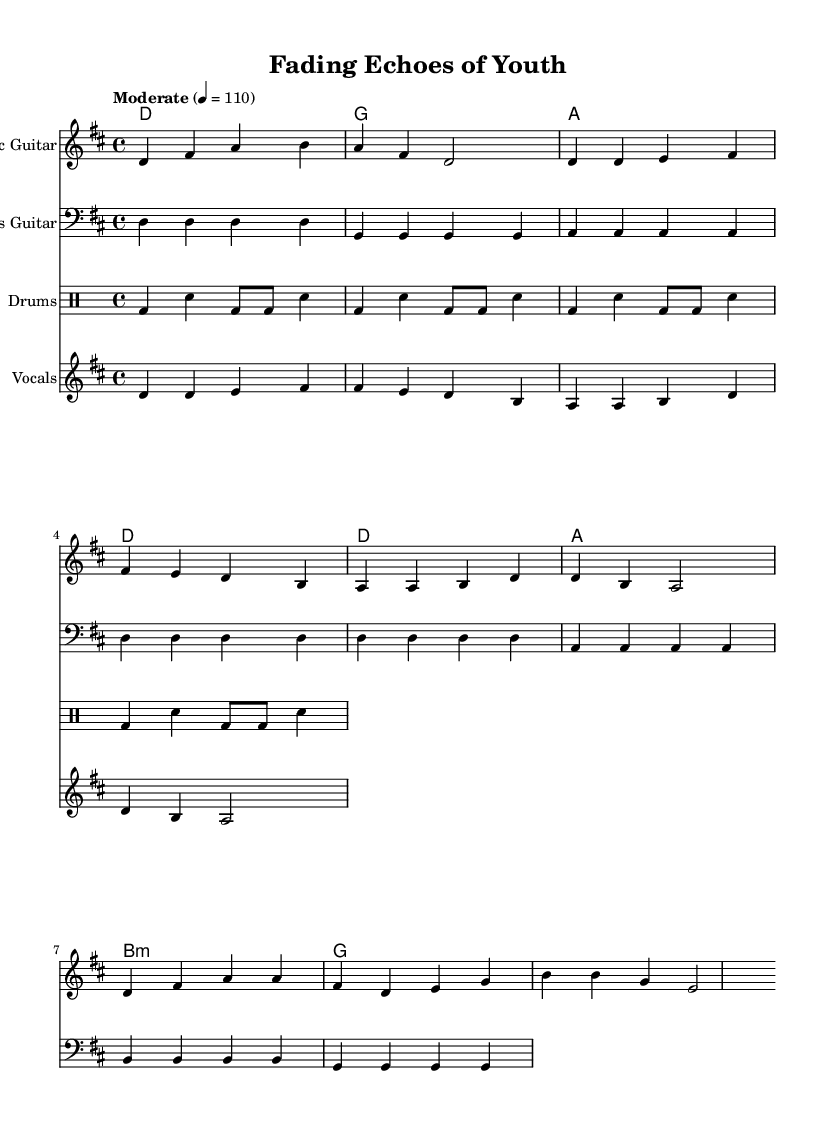What is the key signature of this music? The key signature is D major, which has two sharps (F# and C#) indicated by the key signature at the beginning of the staff.
Answer: D major What is the time signature of this music? The time signature is 4/4, as indicated at the beginning of the score, meaning there are four beats in each measure, and the quarter note gets one beat.
Answer: 4/4 What is the tempo marking for this piece? The tempo is marked as "Moderate" with a metronome marking of 110 beats per minute, showing the intended speed at which the piece should be played.
Answer: Moderate 4 = 110 How many measures are in the intro of the song? The intro consists of 4 measures as seen in the electric guitar part, which is the section before the verse begins.
Answer: 4 measures What is the chord progression for the verse? The chord progression for the verse is D, A, B minor, G, as indicated in the chord mode section corresponding to the vocal part.
Answer: D, A, B minor, G Which instrument plays the melody line in this score? The melody line is played by the vocals, which are provided in the staff labeled "Vocals," linked to the lyrics and the main vocal part of the song.
Answer: Vocals In the drums part, what is the pattern for the bass drum? The bass drum pattern alternates with snare hits in every measure, providing a steady rock rhythm that is a common feature in indie rock music.
Answer: Alternating with snare 